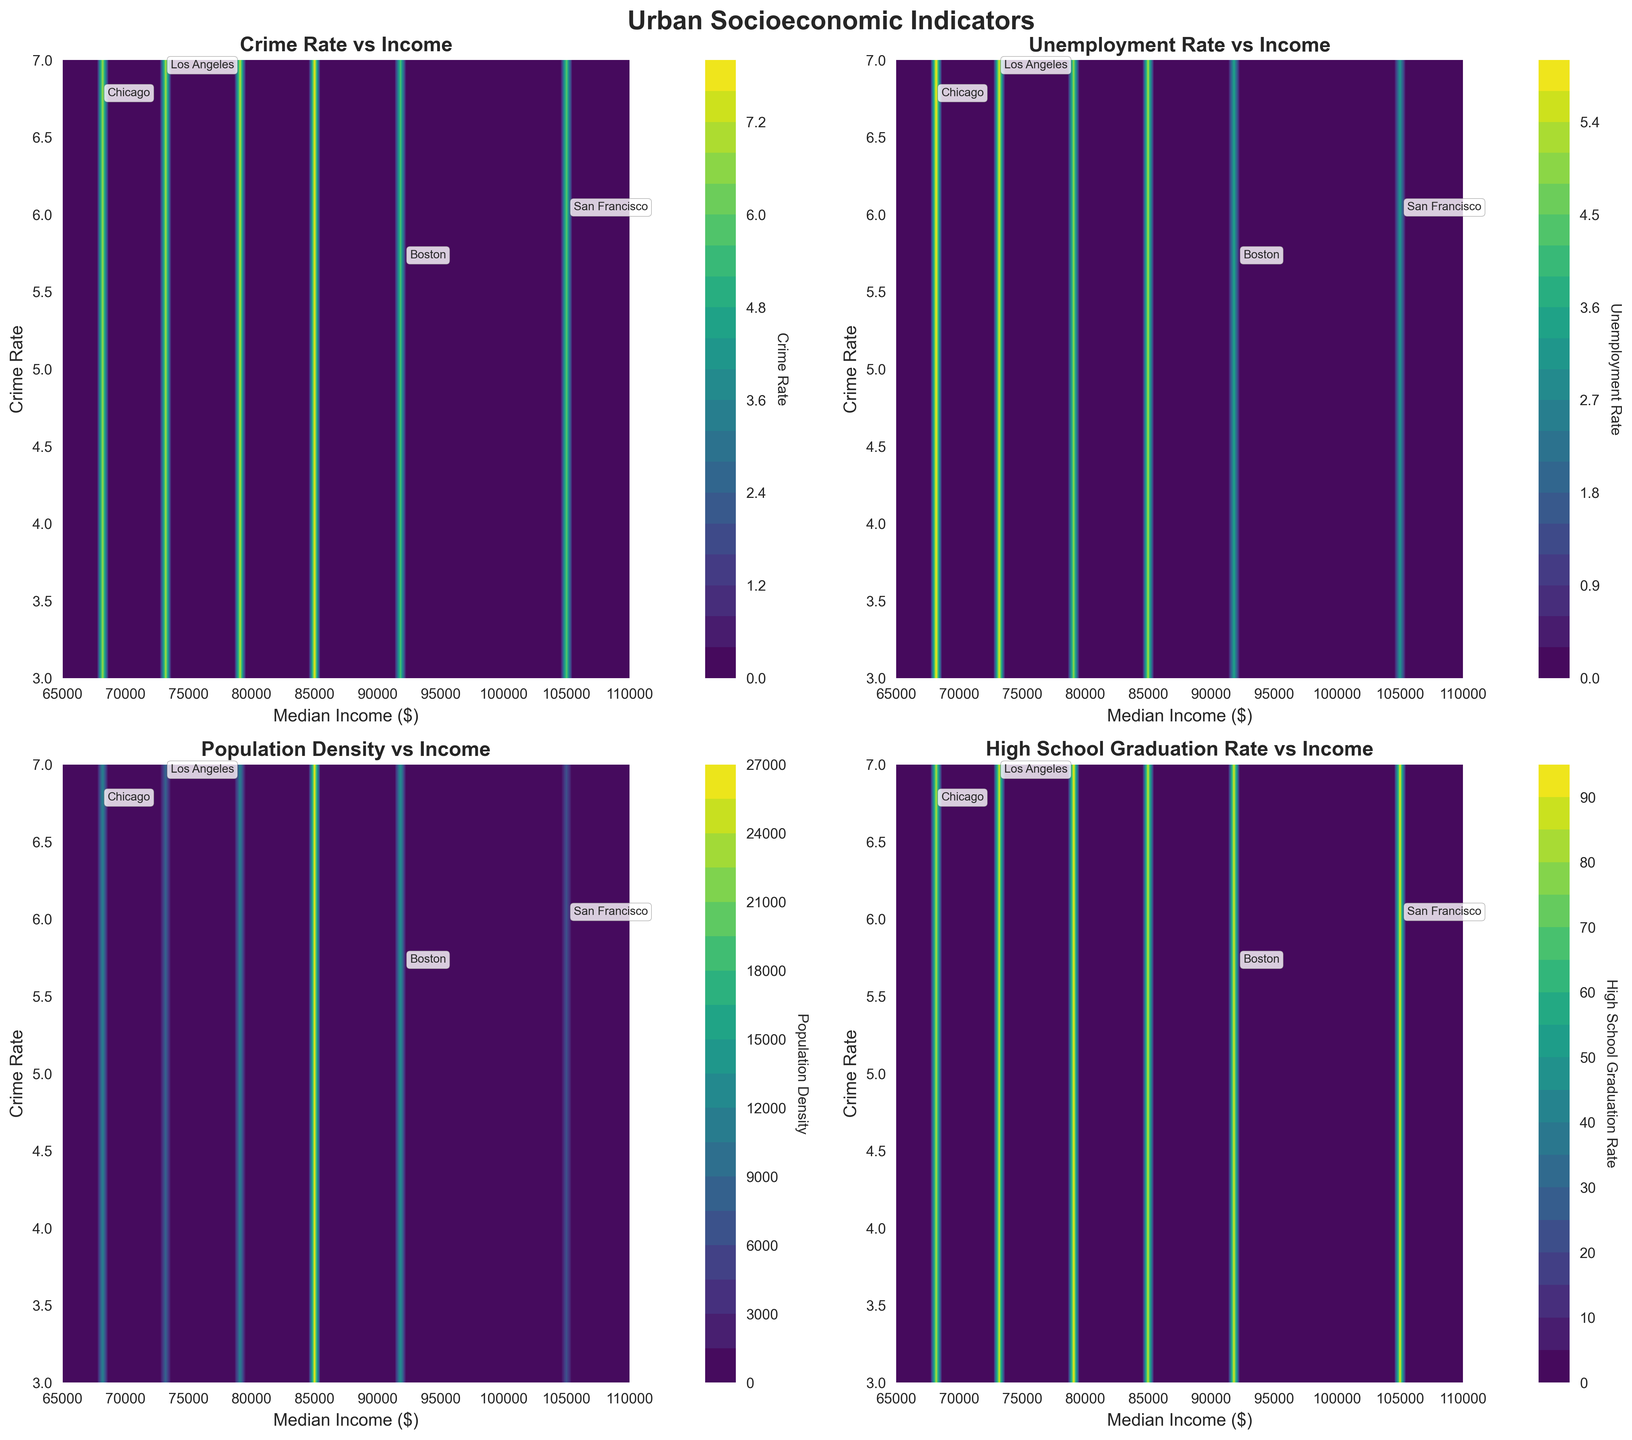What are the titles of the subplots? The figure contains four subplots. Each subplot has a title that indicates what is compared to income. The titles are located at the top of each subplot.
Answer: 'Crime Rate vs Income', 'Unemployment Rate vs Income', 'Population Density vs Income', 'High School Graduation Rate vs Income' Which subplot has the highest contour value for median income near 105000? To determine this, we look at the color gradients in the subplots. The subplot with the highest contour value near a median income of 105,000 is the one that has the most intense (darkest or brightest) colors around this area.
Answer: 'Crime Rate vs Income' How does the crime rate in Washington D.C. compare to other cities at similar income levels? Washington D.C. has a median income around 79,000, with a crime rate of 7.10. By comparing other cities with similar income levels in the contour plot, one can observe whether Washington D.C.'s crime rate is higher or lower.
Answer: Higher than Boston, but lower than New York City On which subplot does San Francisco show the lowest contour value, and what does this indicate? San Francisco has a median income of 105,000, and to find the lowest contour value for this city, we compare all four subplots at this income level. It's the one with the lightest shading around 105,000.
Answer: 'Unemployment Rate vs Income', indicating San Francisco has a low unemployment rate What is the general trend of high school graduation rates with increasing median income? To identify this trend, observe how the contour lines on the 'High School Graduation Rate vs Income' subplot behave. If the shades become lighter (indicating higher values) as we move right on the x-axis (higher incomes), then there is an upward trend.
Answer: Increasing Which city has the lowest crime rate, and does this correlate with its median income? Look for the city with the lowest value on the 'Crime Rate vs Income' subplot. Then check the median income for that city in the axes.
Answer: San Francisco with a crime rate of 5.98 and a high median income of 105,000, indicating a negative correlation How does population density relate to median income for New York City? Find New York City on the 'Population Density vs Income' subplot. Observe the contour values around its median income of 85,000 to see how population density is represented.
Answer: Very high, as indicated by the darkest contour What is the unemployment rate trend across different income levels for Chicago? Locate Chicago on the 'Unemployment Rate vs Income' subplot. Observing the contours around its median income of 68,000, we can infer how the city's value compares with nearby income levels.
Answer: Stable to slightly high Can we infer a correlation between income and high school graduation rates from the given data? By observing the 'High School Graduation Rate vs Income' subplot, we look at how graduation rates change with respect to increasing median incomes. If there's a clear trend where higher incomes result in higher graduation rates, we can infer a positive correlation.
Answer: Yes, positive correlation Which subplot has a more uniform distribution of values across different income levels? A uniform distribution would mean less variation across different income levels. Check all subplots to see which one has the smoothest transition in contour colors.
Answer: 'High School Graduation Rate vs Income' 